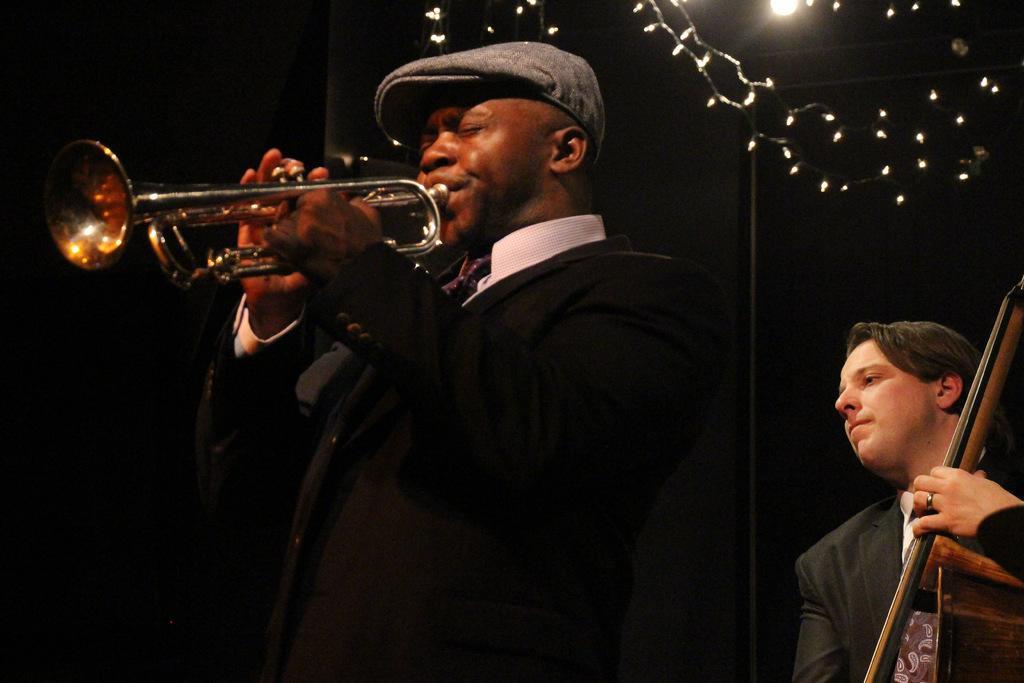Can you describe this image briefly? In this image in the front there is a man standing and playing a musical instrument. On the right side there is a person standing and holding a musical instrument in his hand. On the top there are lights. 